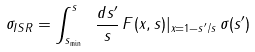Convert formula to latex. <formula><loc_0><loc_0><loc_500><loc_500>\sigma _ { I S R } = \int _ { s _ { \min } } ^ { s } \ { \frac { d s ^ { \prime } } { s } } \, F ( x , s ) | _ { x = 1 - s ^ { \prime } / s } \, \sigma ( s ^ { \prime } )</formula> 